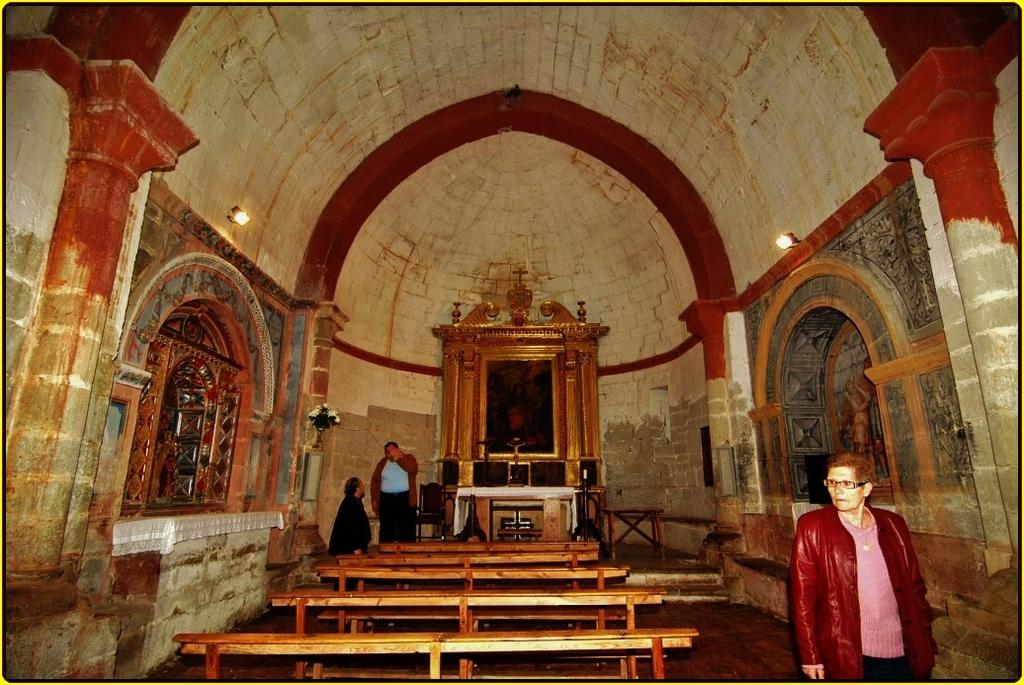What type of space is depicted in the image? The image shows an inner view of a room. What structural elements can be seen in the room? There are walls, pillars, and statues in the room. What furniture is present in the room? There are tables and benches in the room. Are there any people in the room? Yes, there are persons standing on the floor in the room. What type of lighting is available in the room? There are electric lights in the room. What type of harmony does the mom play on the piano in the image? There is no piano or mom present in the image. What type of glove is the person wearing in the image? There is no glove visible in the image; the persons standing on the floor are not wearing any gloves. 